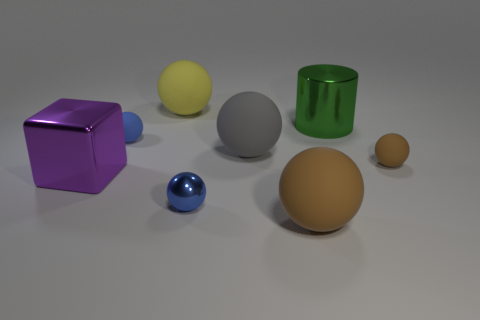Subtract all gray rubber spheres. How many spheres are left? 5 Add 1 gray things. How many objects exist? 9 Subtract all brown cylinders. How many blue spheres are left? 2 Subtract 3 balls. How many balls are left? 3 Subtract all blue spheres. How many spheres are left? 4 Subtract all big spheres. Subtract all big metal cylinders. How many objects are left? 4 Add 2 yellow matte objects. How many yellow matte objects are left? 3 Add 7 big brown things. How many big brown things exist? 8 Subtract 0 green spheres. How many objects are left? 8 Subtract all cubes. How many objects are left? 7 